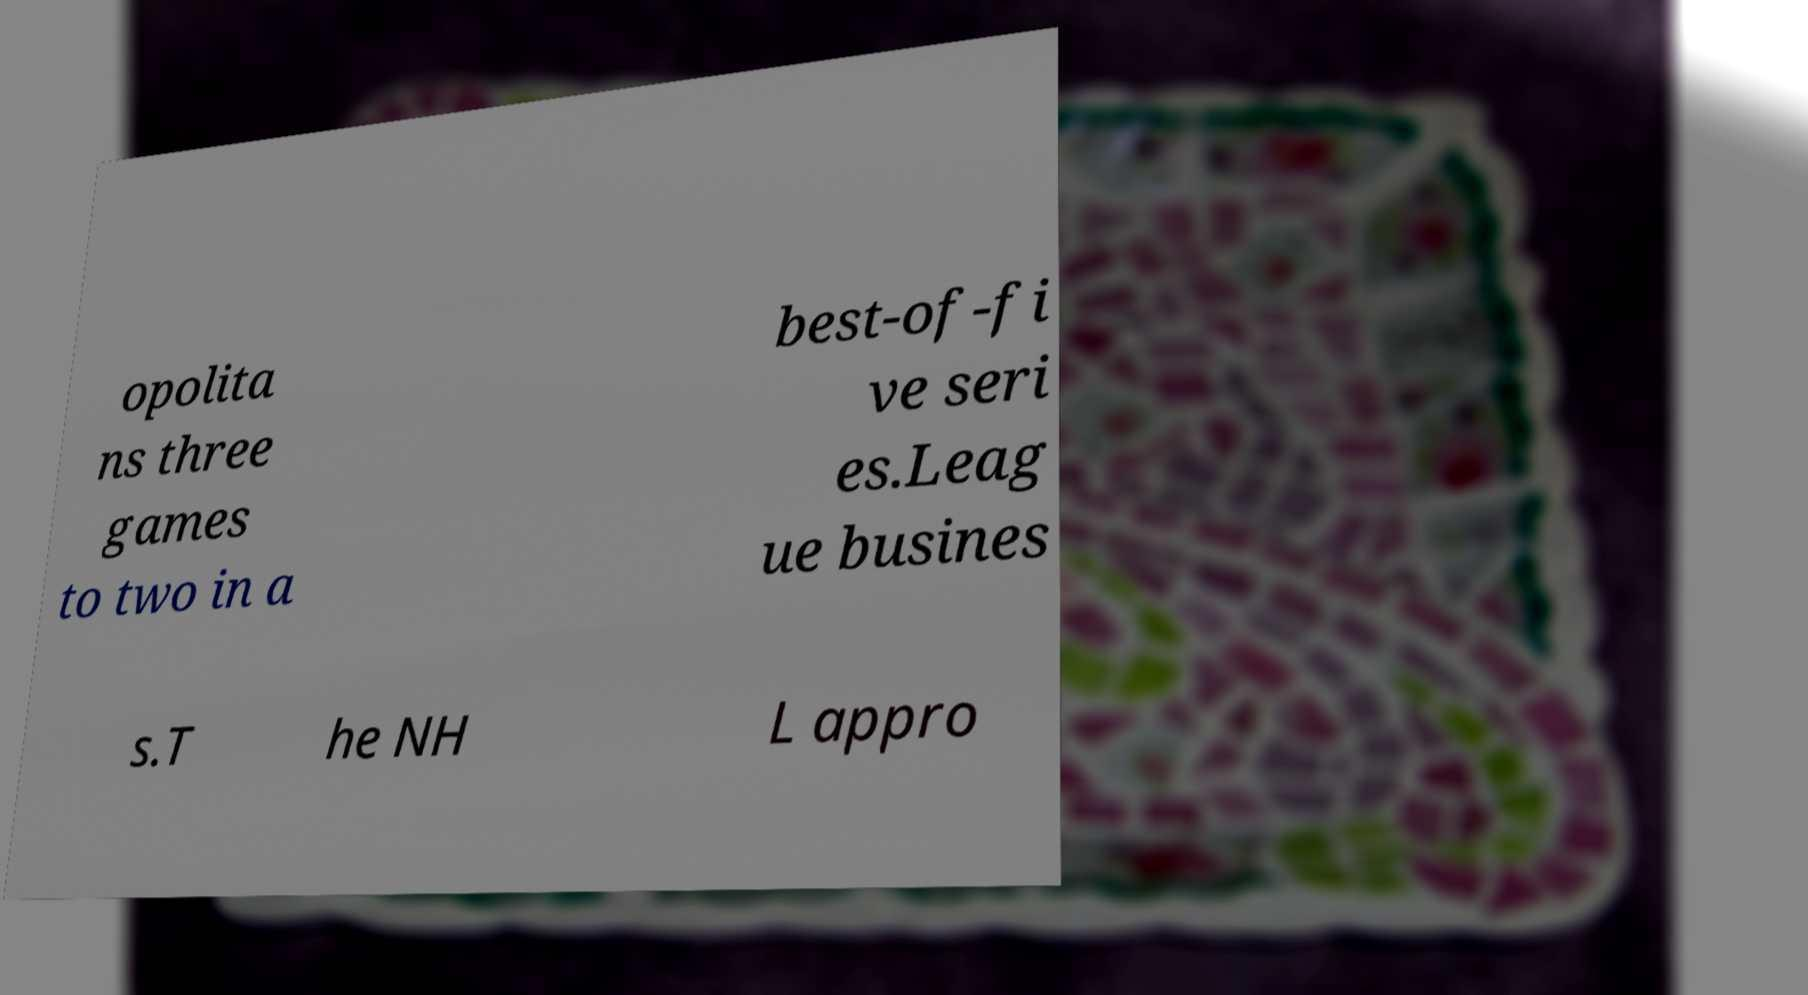Can you accurately transcribe the text from the provided image for me? opolita ns three games to two in a best-of-fi ve seri es.Leag ue busines s.T he NH L appro 